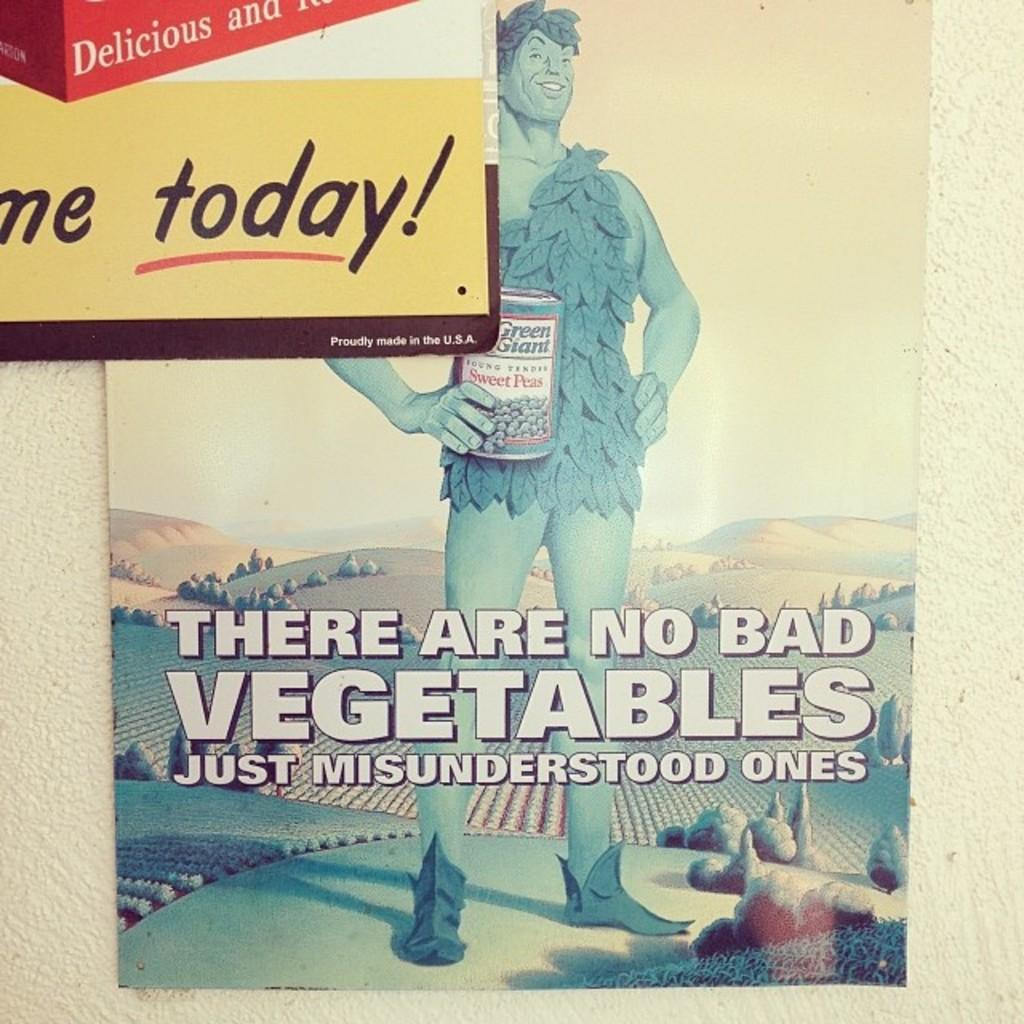What is the main subject of the image? The main subject of the image is a cover page. What can be found on the cover page? The cover page contains text and a man. Can you describe the man on the cover page? Unfortunately, the image does not provide enough detail to describe the man. What type of honey is being poured on the page? There is no honey present in the image. 